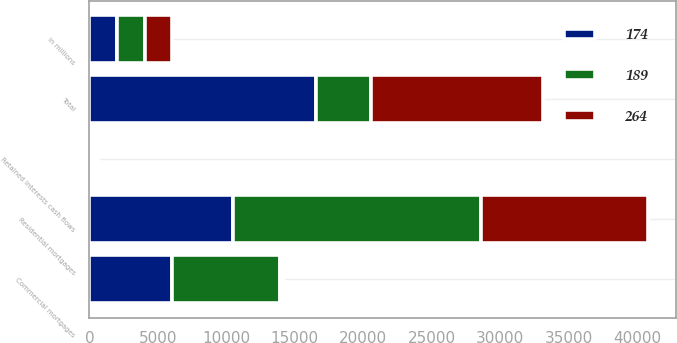Convert chart. <chart><loc_0><loc_0><loc_500><loc_500><stacked_bar_chart><ecel><fcel>in millions<fcel>Residential mortgages<fcel>Commercial mortgages<fcel>Total<fcel>Retained interests cash flows<nl><fcel>189<fcel>2017<fcel>18142<fcel>7872<fcel>4030<fcel>264<nl><fcel>264<fcel>2016<fcel>12164<fcel>233<fcel>12578<fcel>189<nl><fcel>174<fcel>2015<fcel>10479<fcel>6043<fcel>16522<fcel>174<nl></chart> 